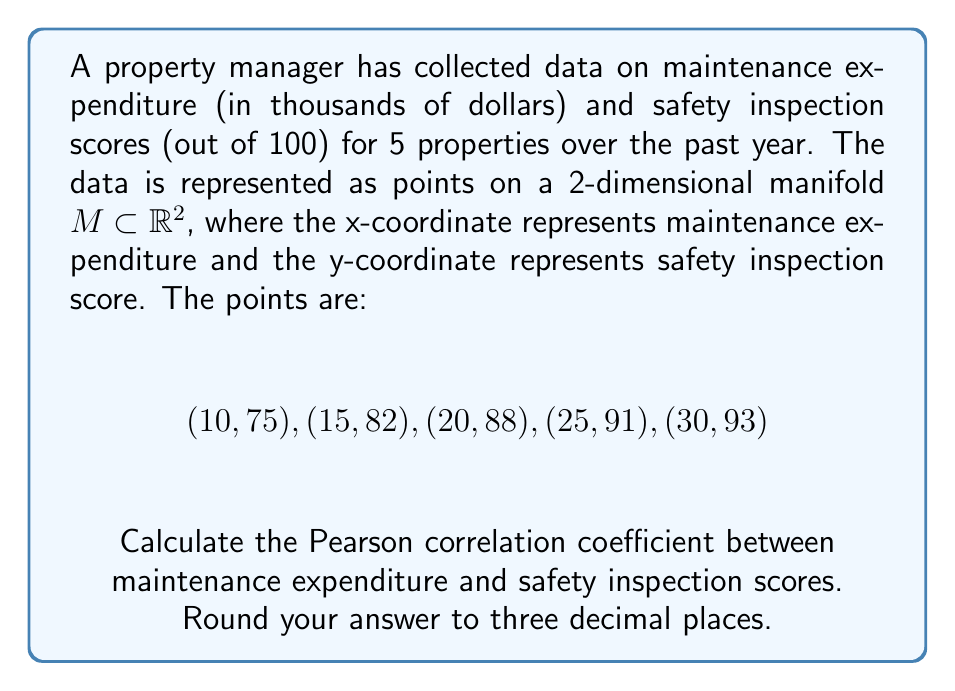What is the answer to this math problem? To calculate the Pearson correlation coefficient, we'll follow these steps:

1) First, we need to calculate the means of x (maintenance expenditure) and y (safety inspection scores):

   $\bar{x} = \frac{10 + 15 + 20 + 25 + 30}{5} = 20$
   $\bar{y} = \frac{75 + 82 + 88 + 91 + 93}{5} = 85.8$

2) Now, we calculate the deviations from the mean for each point:

   $(x_i - \bar{x})$: $-10, -5, 0, 5, 10$
   $(y_i - \bar{y})$: $-10.8, -3.8, 2.2, 5.2, 7.2$

3) We calculate the products of these deviations:

   $(x_i - \bar{x})(y_i - \bar{y})$: $108, 19, 0, 26, 72$

4) Now we can calculate the numerator of the correlation coefficient:

   $\sum (x_i - \bar{x})(y_i - \bar{y}) = 108 + 19 + 0 + 26 + 72 = 225$

5) For the denominator, we need:

   $\sum (x_i - \bar{x})^2 = 100 + 25 + 0 + 25 + 100 = 250$
   $\sum (y_i - \bar{y})^2 = 116.64 + 14.44 + 4.84 + 27.04 + 51.84 = 214.8$

6) The Pearson correlation coefficient is given by:

   $$r = \frac{\sum (x_i - \bar{x})(y_i - \bar{y})}{\sqrt{\sum (x_i - \bar{x})^2 \sum (y_i - \bar{y})^2}}$$

7) Plugging in our values:

   $$r = \frac{225}{\sqrt{250 * 214.8}} = \frac{225}{231.733} \approx 0.971$$
Answer: 0.971 